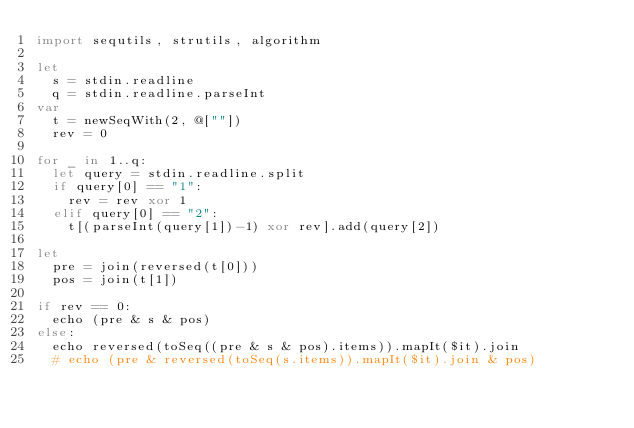Convert code to text. <code><loc_0><loc_0><loc_500><loc_500><_Nim_>import sequtils, strutils, algorithm

let
  s = stdin.readline
  q = stdin.readline.parseInt
var
  t = newSeqWith(2, @[""])
  rev = 0

for _ in 1..q:
  let query = stdin.readline.split
  if query[0] == "1":
    rev = rev xor 1
  elif query[0] == "2":
    t[(parseInt(query[1])-1) xor rev].add(query[2])

let
  pre = join(reversed(t[0]))
  pos = join(t[1])

if rev == 0:
  echo (pre & s & pos)
else:
  echo reversed(toSeq((pre & s & pos).items)).mapIt($it).join
  # echo (pre & reversed(toSeq(s.items)).mapIt($it).join & pos)
</code> 